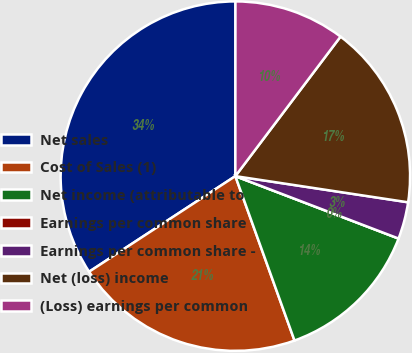Convert chart to OTSL. <chart><loc_0><loc_0><loc_500><loc_500><pie_chart><fcel>Net sales<fcel>Cost of Sales (1)<fcel>Net income (attributable to<fcel>Earnings per common share<fcel>Earnings per common share -<fcel>Net (loss) income<fcel>(Loss) earnings per common<nl><fcel>34.22%<fcel>21.28%<fcel>13.69%<fcel>0.0%<fcel>3.42%<fcel>17.11%<fcel>10.27%<nl></chart> 